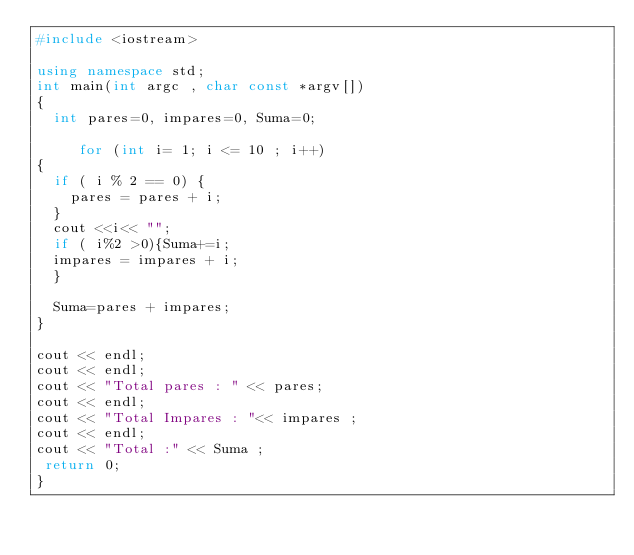<code> <loc_0><loc_0><loc_500><loc_500><_C++_>#include <iostream>

using namespace std;
int main(int argc , char const *argv[])
{
	int pares=0, impares=0, Suma=0;
	
     for (int i= 1; i <= 10 ; i++)	  
{
	if ( i % 2 == 0) {
		pares = pares + i;
	}
	cout <<i<< "";
	if ( i%2 >0){Suma+=i;
	impares = impares + i;
	}
	
	Suma=pares + impares;
}

cout << endl;
cout << endl;
cout << "Total pares : " << pares;
cout << endl;
cout << "Total Impares : "<< impares ;
cout << endl;
cout << "Total :" << Suma ; 
 return 0;
}
</code> 